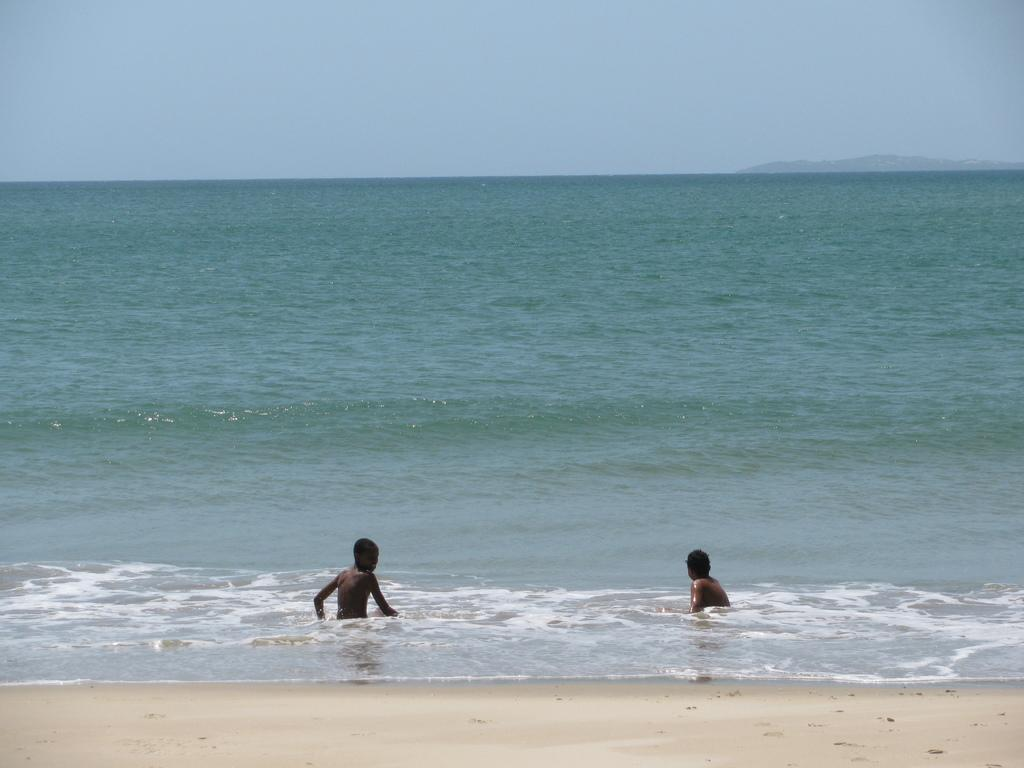How many children are present in the image? There are two kids in the image. What is the primary setting or environment in which the kids are located? The kids are in water. What color is the calendar on the kids' stomachs in the image? There is no calendar present in the image, and the kids are not holding any calendars. 